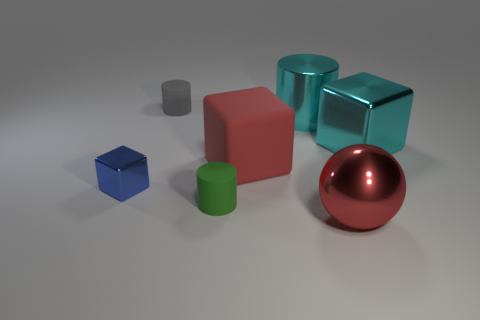There is a big red object left of the big thing that is in front of the metal cube that is to the left of the red matte block; what is it made of?
Your response must be concise. Rubber. Is the gray thing the same size as the rubber cube?
Keep it short and to the point. No. What is the material of the tiny blue object?
Provide a succinct answer. Metal. What is the material of the big cube that is the same color as the big cylinder?
Your answer should be compact. Metal. There is a matte object that is in front of the red rubber object; is it the same shape as the tiny blue thing?
Provide a succinct answer. No. How many objects are either small blue cylinders or large cyan blocks?
Your answer should be very brief. 1. Is the material of the red object that is in front of the small blue block the same as the large cyan block?
Your answer should be very brief. Yes. The green matte cylinder has what size?
Your response must be concise. Small. There is a big object that is the same color as the sphere; what is its shape?
Provide a short and direct response. Cube. What number of blocks are either blue objects or large shiny objects?
Offer a terse response. 2. 